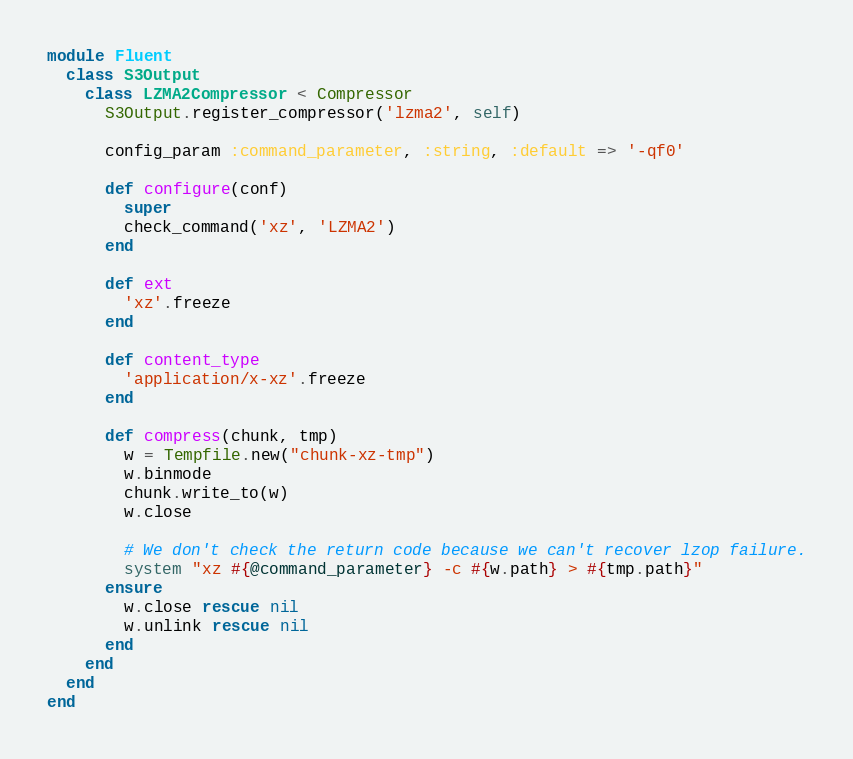Convert code to text. <code><loc_0><loc_0><loc_500><loc_500><_Ruby_>module Fluent
  class S3Output
    class LZMA2Compressor < Compressor
      S3Output.register_compressor('lzma2', self)

      config_param :command_parameter, :string, :default => '-qf0'

      def configure(conf)
        super
        check_command('xz', 'LZMA2')
      end

      def ext
        'xz'.freeze
      end

      def content_type
        'application/x-xz'.freeze
      end

      def compress(chunk, tmp)
        w = Tempfile.new("chunk-xz-tmp")
        w.binmode
        chunk.write_to(w)
        w.close

        # We don't check the return code because we can't recover lzop failure.
        system "xz #{@command_parameter} -c #{w.path} > #{tmp.path}"
      ensure
        w.close rescue nil
        w.unlink rescue nil
      end
    end
  end
end
</code> 